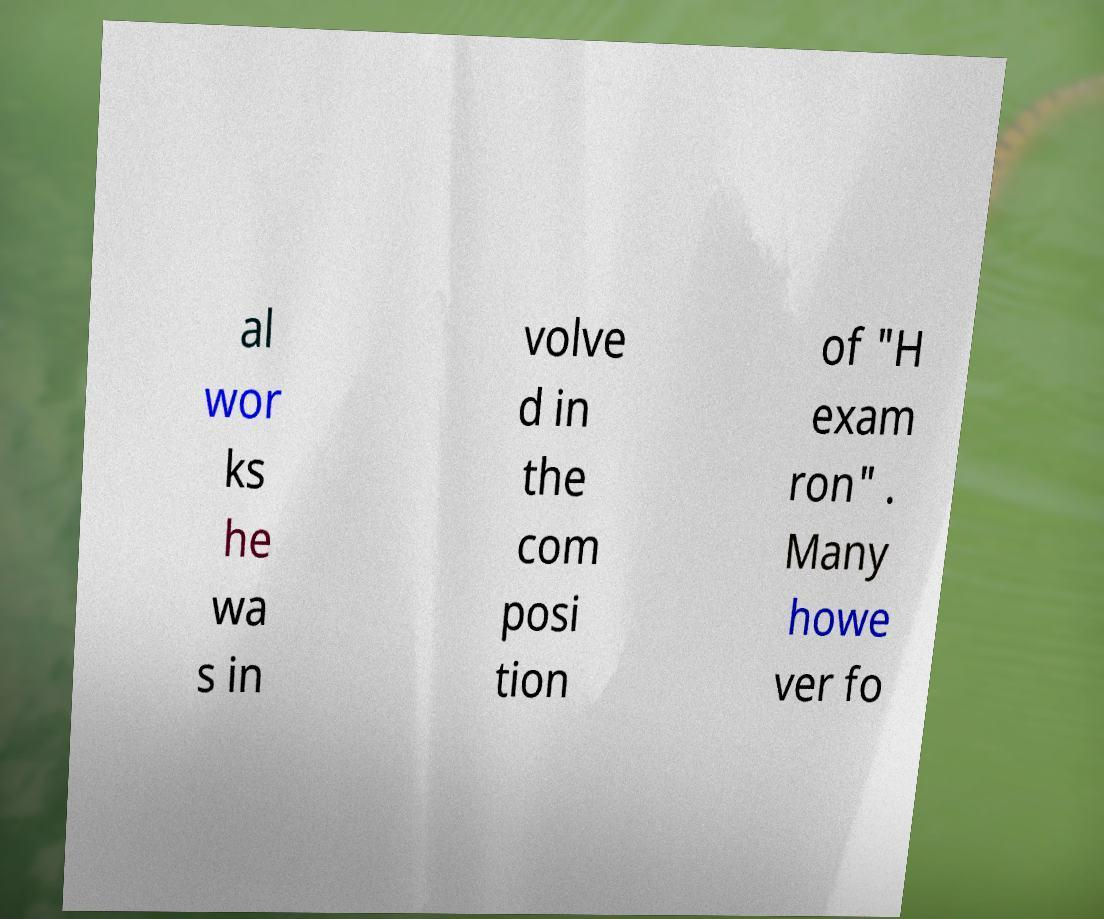Can you read and provide the text displayed in the image?This photo seems to have some interesting text. Can you extract and type it out for me? al wor ks he wa s in volve d in the com posi tion of "H exam ron" . Many howe ver fo 